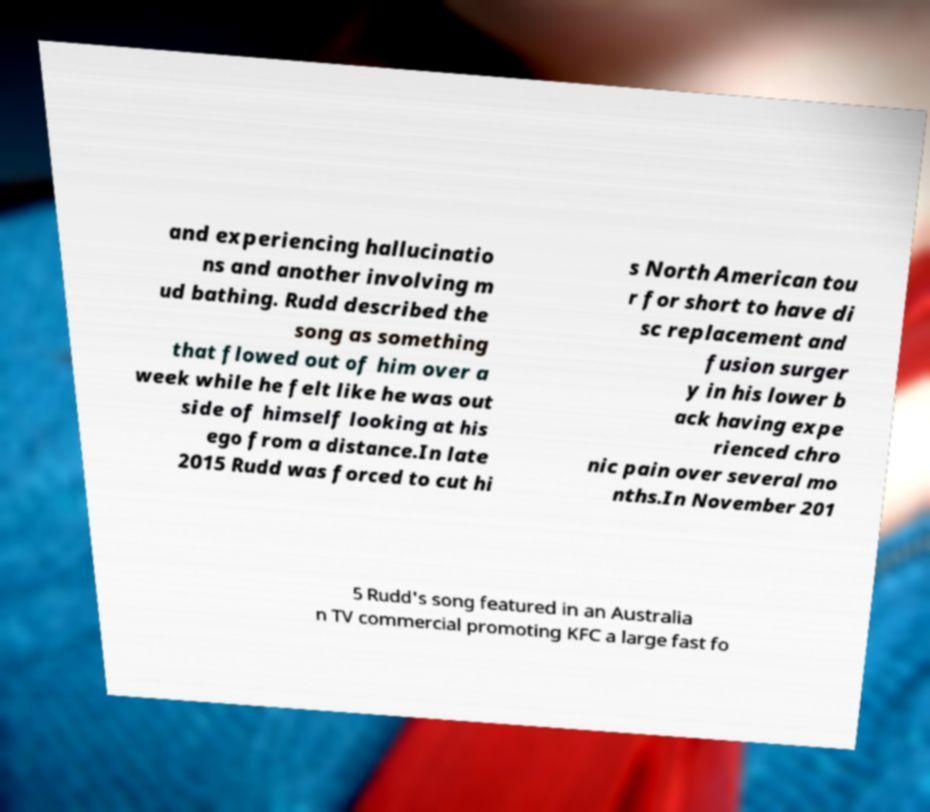Could you assist in decoding the text presented in this image and type it out clearly? and experiencing hallucinatio ns and another involving m ud bathing. Rudd described the song as something that flowed out of him over a week while he felt like he was out side of himself looking at his ego from a distance.In late 2015 Rudd was forced to cut hi s North American tou r for short to have di sc replacement and fusion surger y in his lower b ack having expe rienced chro nic pain over several mo nths.In November 201 5 Rudd's song featured in an Australia n TV commercial promoting KFC a large fast fo 